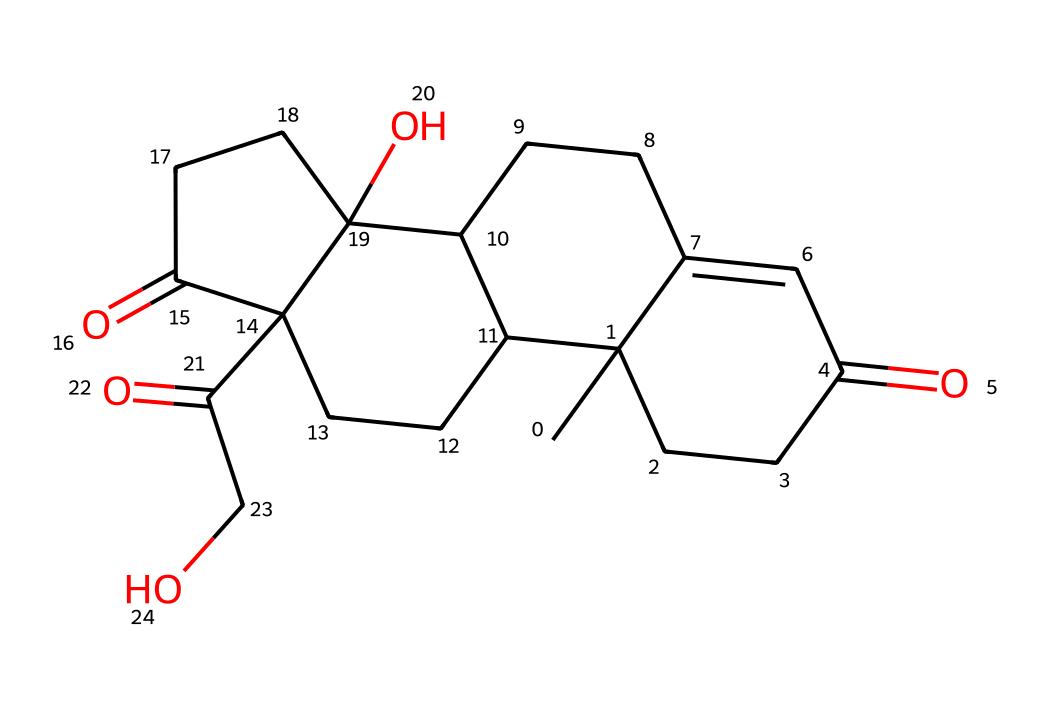What is the molecular formula for cortisol? To determine the molecular formula, consider the atoms represented in the SMILES notation. By interpreting the structure, we identify the number of carbon (C), hydrogen (H), and oxygen (O) atoms: there are 21 carbons, 30 hydrogens, and 5 oxygens. Thus, the molecular formula is C21H30O5.
Answer: C21H30O5 How many ring structures are present in cortisol? Analyzing the SMILES representation shows that cortisol has four interconnected rings in its structure. The rings are denoted by the use of numbers in the SMILES, indicating shared atoms.
Answer: 4 What functional groups are present in cortisol? By examining the chemical structure in the SMILES, we can identify functional groups such as ketones (C=O) and hydroxyl groups (–OH), confirming the presence of multiple carbonyl (C=O) and a hydroxyl (–OH) functional group.
Answer: ketones and hydroxyl groups What is cortisol classified as in biological terms? Cortisol acts as a glucocorticoid hormone in the body, which is involved in the regulation of various functions such as metabolism and stress response. By examining its role in physiology and its derived structure, it is classified accordingly.
Answer: glucocorticoid How does cortisol affect blood sugar levels? Cortisol primarily increases blood sugar levels by promoting gluconeogenesis and inhibiting glucose uptake by tissues. Understanding how cortisol interacts with metabolic processes helps explain its elevating effect on glucose levels in the bloodstream.
Answer: increases blood sugar levels What is the significance of cortisol's stereochemistry? The stereochemistry of cortisol impacts its biological activity and receptor interactions. The Specific configuration of certain carbon atoms in its structure directly influences its functionality in processes like metabolism and stress relief.
Answer: impacts biological activity What would be a potential result of prolonged high cortisol levels? Long-term elevation of cortisol levels can lead to various health problems, including weight gain and immune suppression. Evaluating its physiological effects reveals these negative outcomes associated with chronic stress conditions.
Answer: health problems like weight gain and immune suppression 